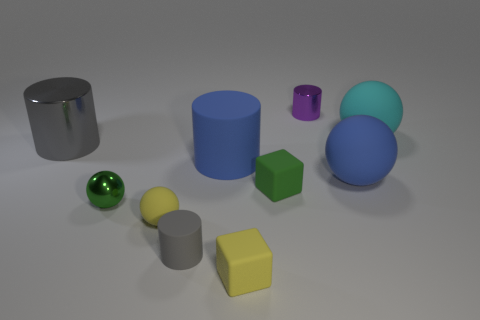The matte sphere that is the same color as the large rubber cylinder is what size?
Keep it short and to the point. Large. The tiny object that is the same color as the small metallic ball is what shape?
Offer a very short reply. Cube. Is there any other thing that has the same color as the metallic ball?
Make the answer very short. Yes. There is a shiny cylinder that is behind the big cyan sphere; is its size the same as the gray cylinder in front of the small yellow matte sphere?
Offer a very short reply. Yes. Is the number of yellow rubber blocks behind the purple cylinder the same as the number of small green objects behind the big gray cylinder?
Give a very brief answer. Yes. Is the size of the green matte thing the same as the rubber ball that is on the left side of the purple cylinder?
Keep it short and to the point. Yes. Is there a yellow rubber cube left of the big cylinder to the left of the large blue cylinder?
Offer a very short reply. No. Are there any small purple shiny things of the same shape as the tiny gray thing?
Provide a succinct answer. Yes. There is a big blue thing that is behind the blue matte object that is in front of the large blue rubber cylinder; how many matte spheres are left of it?
Ensure brevity in your answer.  1. There is a large rubber cylinder; is it the same color as the metal cylinder that is left of the small purple metal cylinder?
Ensure brevity in your answer.  No. 